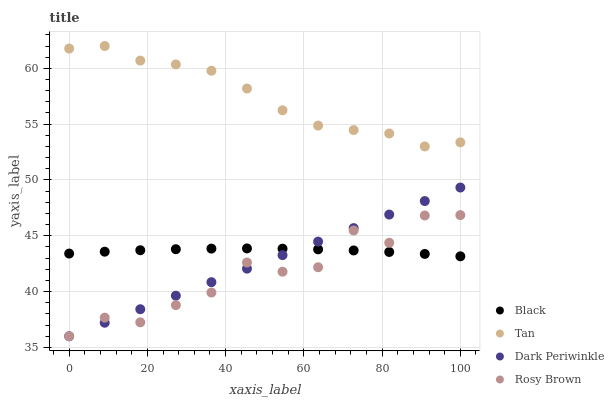Does Rosy Brown have the minimum area under the curve?
Answer yes or no. Yes. Does Tan have the maximum area under the curve?
Answer yes or no. Yes. Does Black have the minimum area under the curve?
Answer yes or no. No. Does Black have the maximum area under the curve?
Answer yes or no. No. Is Dark Periwinkle the smoothest?
Answer yes or no. Yes. Is Rosy Brown the roughest?
Answer yes or no. Yes. Is Black the smoothest?
Answer yes or no. No. Is Black the roughest?
Answer yes or no. No. Does Rosy Brown have the lowest value?
Answer yes or no. Yes. Does Black have the lowest value?
Answer yes or no. No. Does Tan have the highest value?
Answer yes or no. Yes. Does Rosy Brown have the highest value?
Answer yes or no. No. Is Dark Periwinkle less than Tan?
Answer yes or no. Yes. Is Tan greater than Rosy Brown?
Answer yes or no. Yes. Does Black intersect Dark Periwinkle?
Answer yes or no. Yes. Is Black less than Dark Periwinkle?
Answer yes or no. No. Is Black greater than Dark Periwinkle?
Answer yes or no. No. Does Dark Periwinkle intersect Tan?
Answer yes or no. No. 